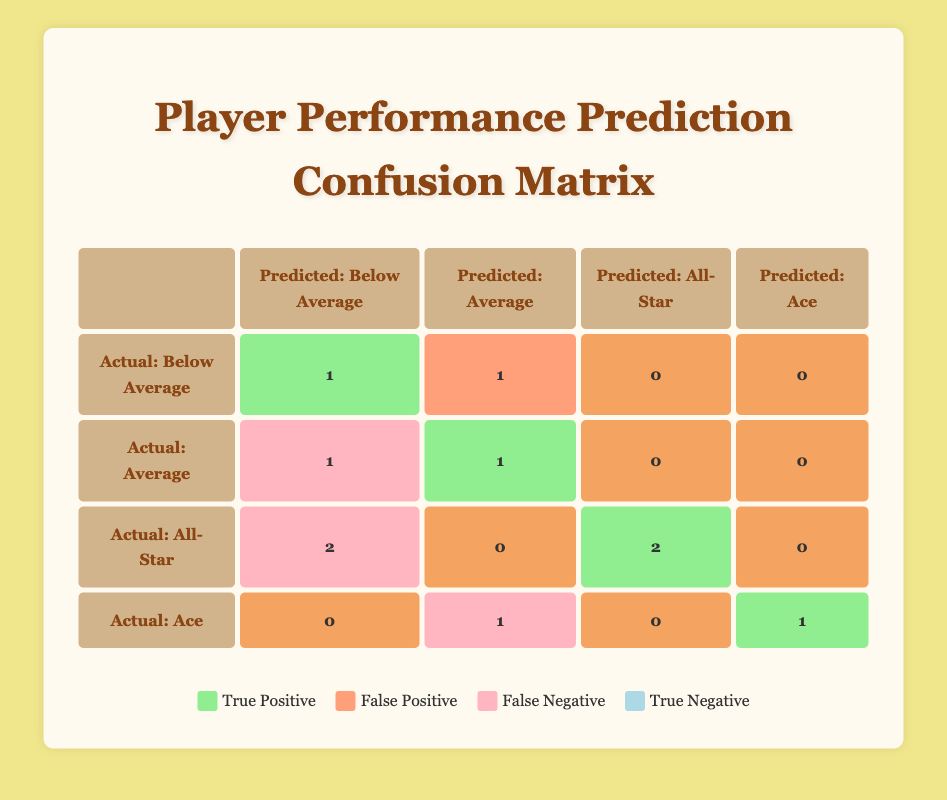What is the total number of True Positives in the confusion matrix? To find the total number of True Positives, we can look at the counts in the confusion matrix for True Positives, which are located in each row where the actual performance matches the predicted performance. Specifically, this includes the counts for "Below Average" (1), "Average" (1), "All-Star" (2), and "Ace" (1), making the total 1 + 1 + 2 + 1 = 5.
Answer: 5 How many players were predicted to be All-Stars but actually performed below average? From the table, we can see that there are 2 instances where players were actually All-Stars but were not predicted correctly. Specifically, these players are Buster Posey and Mookie Betts, who were both predicted to be below average, making the count 2.
Answer: 2 What is the count for players who had a False Positive prediction? From the table, a False Positive occurs when a player is predicted to have a better performance than their actual performance. There is 1 instance where Joey Gallo was predicted as Average but was actually below average. Thus, the count for False Positives is 1.
Answer: 1 What percentage of players were correctly predicted as Aces? There are 2 players in total who were actual Aces, and only 1 of them (Jacob deGrom) was correctly predicted as an Ace. To find the percentage, we divide the correct predictions (1) by the total actual Aces (2) and multiply by 100, resulting in (1/2) * 100 = 50%.
Answer: 50% Is it true that more players were predicted to be Below Average than were actually Below Average? In the matrix, the count of players predicted as Below Average is 3 (1 True Positive and 1 False Positive), while the actual count of players who performed Below Average is also 3. Since both numbers are equal, the statement is false.
Answer: No What is the total number of players that were actually All-Stars but predicted otherwise? The count of players who were actually All-Stars but predicted as something else includes 2 players: Buster Posey and Mookie Betts. Thus, the total number is 2.
Answer: 2 What are the False Negative counts for each predicted performance category? We can see that "Below Average" has 1 False Negative (Eloy Jimenez), "Average" has 1 False Negative (Max Scherzer), "All-Star" has 2 False Negatives (Buster Posey and Mookie Betts), and "Ace" has 1 False Negative (for Jacob deGrom). Adding them gives a total count of 1 + 1 + 2 + 1 = 5 False Negatives across categories.
Answer: 5 How many players had a true negative prediction? In the confusion matrix, there are no instances recorded as True Negatives, since all actual performances are accounted for in either True Positives or False Positives/Negatives. Hence, the count is 0.
Answer: 0 